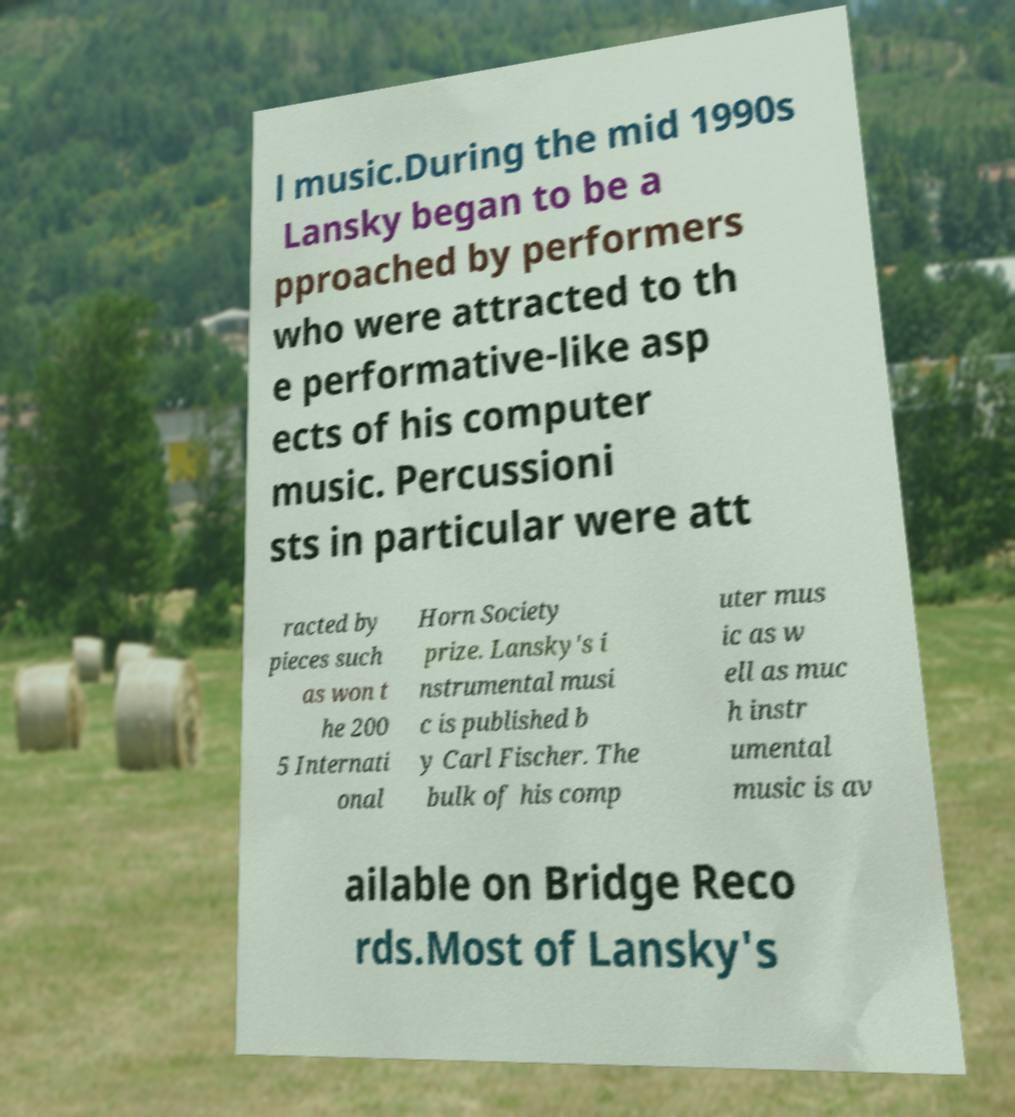There's text embedded in this image that I need extracted. Can you transcribe it verbatim? l music.During the mid 1990s Lansky began to be a pproached by performers who were attracted to th e performative-like asp ects of his computer music. Percussioni sts in particular were att racted by pieces such as won t he 200 5 Internati onal Horn Society prize. Lansky's i nstrumental musi c is published b y Carl Fischer. The bulk of his comp uter mus ic as w ell as muc h instr umental music is av ailable on Bridge Reco rds.Most of Lansky's 